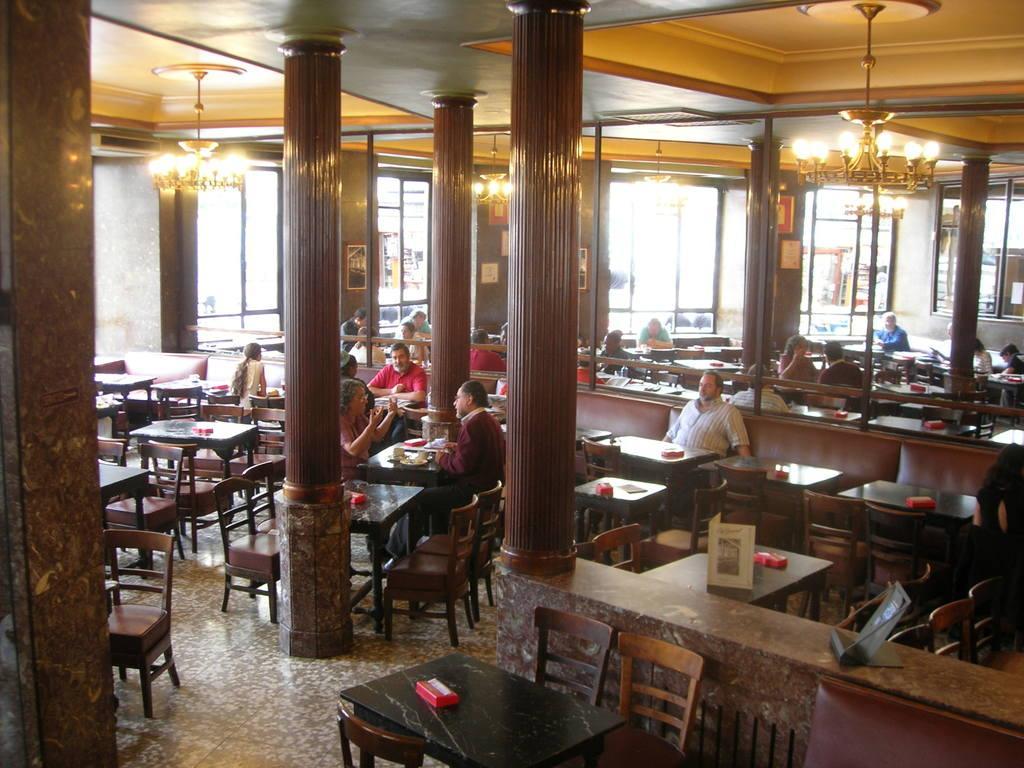Describe this image in one or two sentences. In this image i can see few persons sitting in a chair and there are few tables at the back ground i can see a pillar, window at the top i can see a chandelier. 